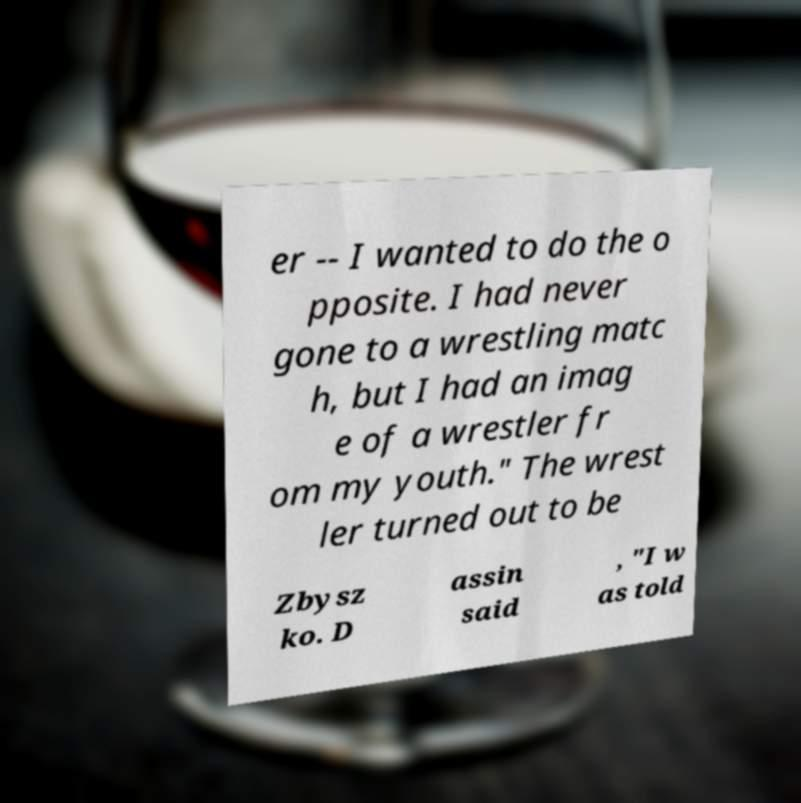There's text embedded in this image that I need extracted. Can you transcribe it verbatim? er -- I wanted to do the o pposite. I had never gone to a wrestling matc h, but I had an imag e of a wrestler fr om my youth." The wrest ler turned out to be Zbysz ko. D assin said , "I w as told 